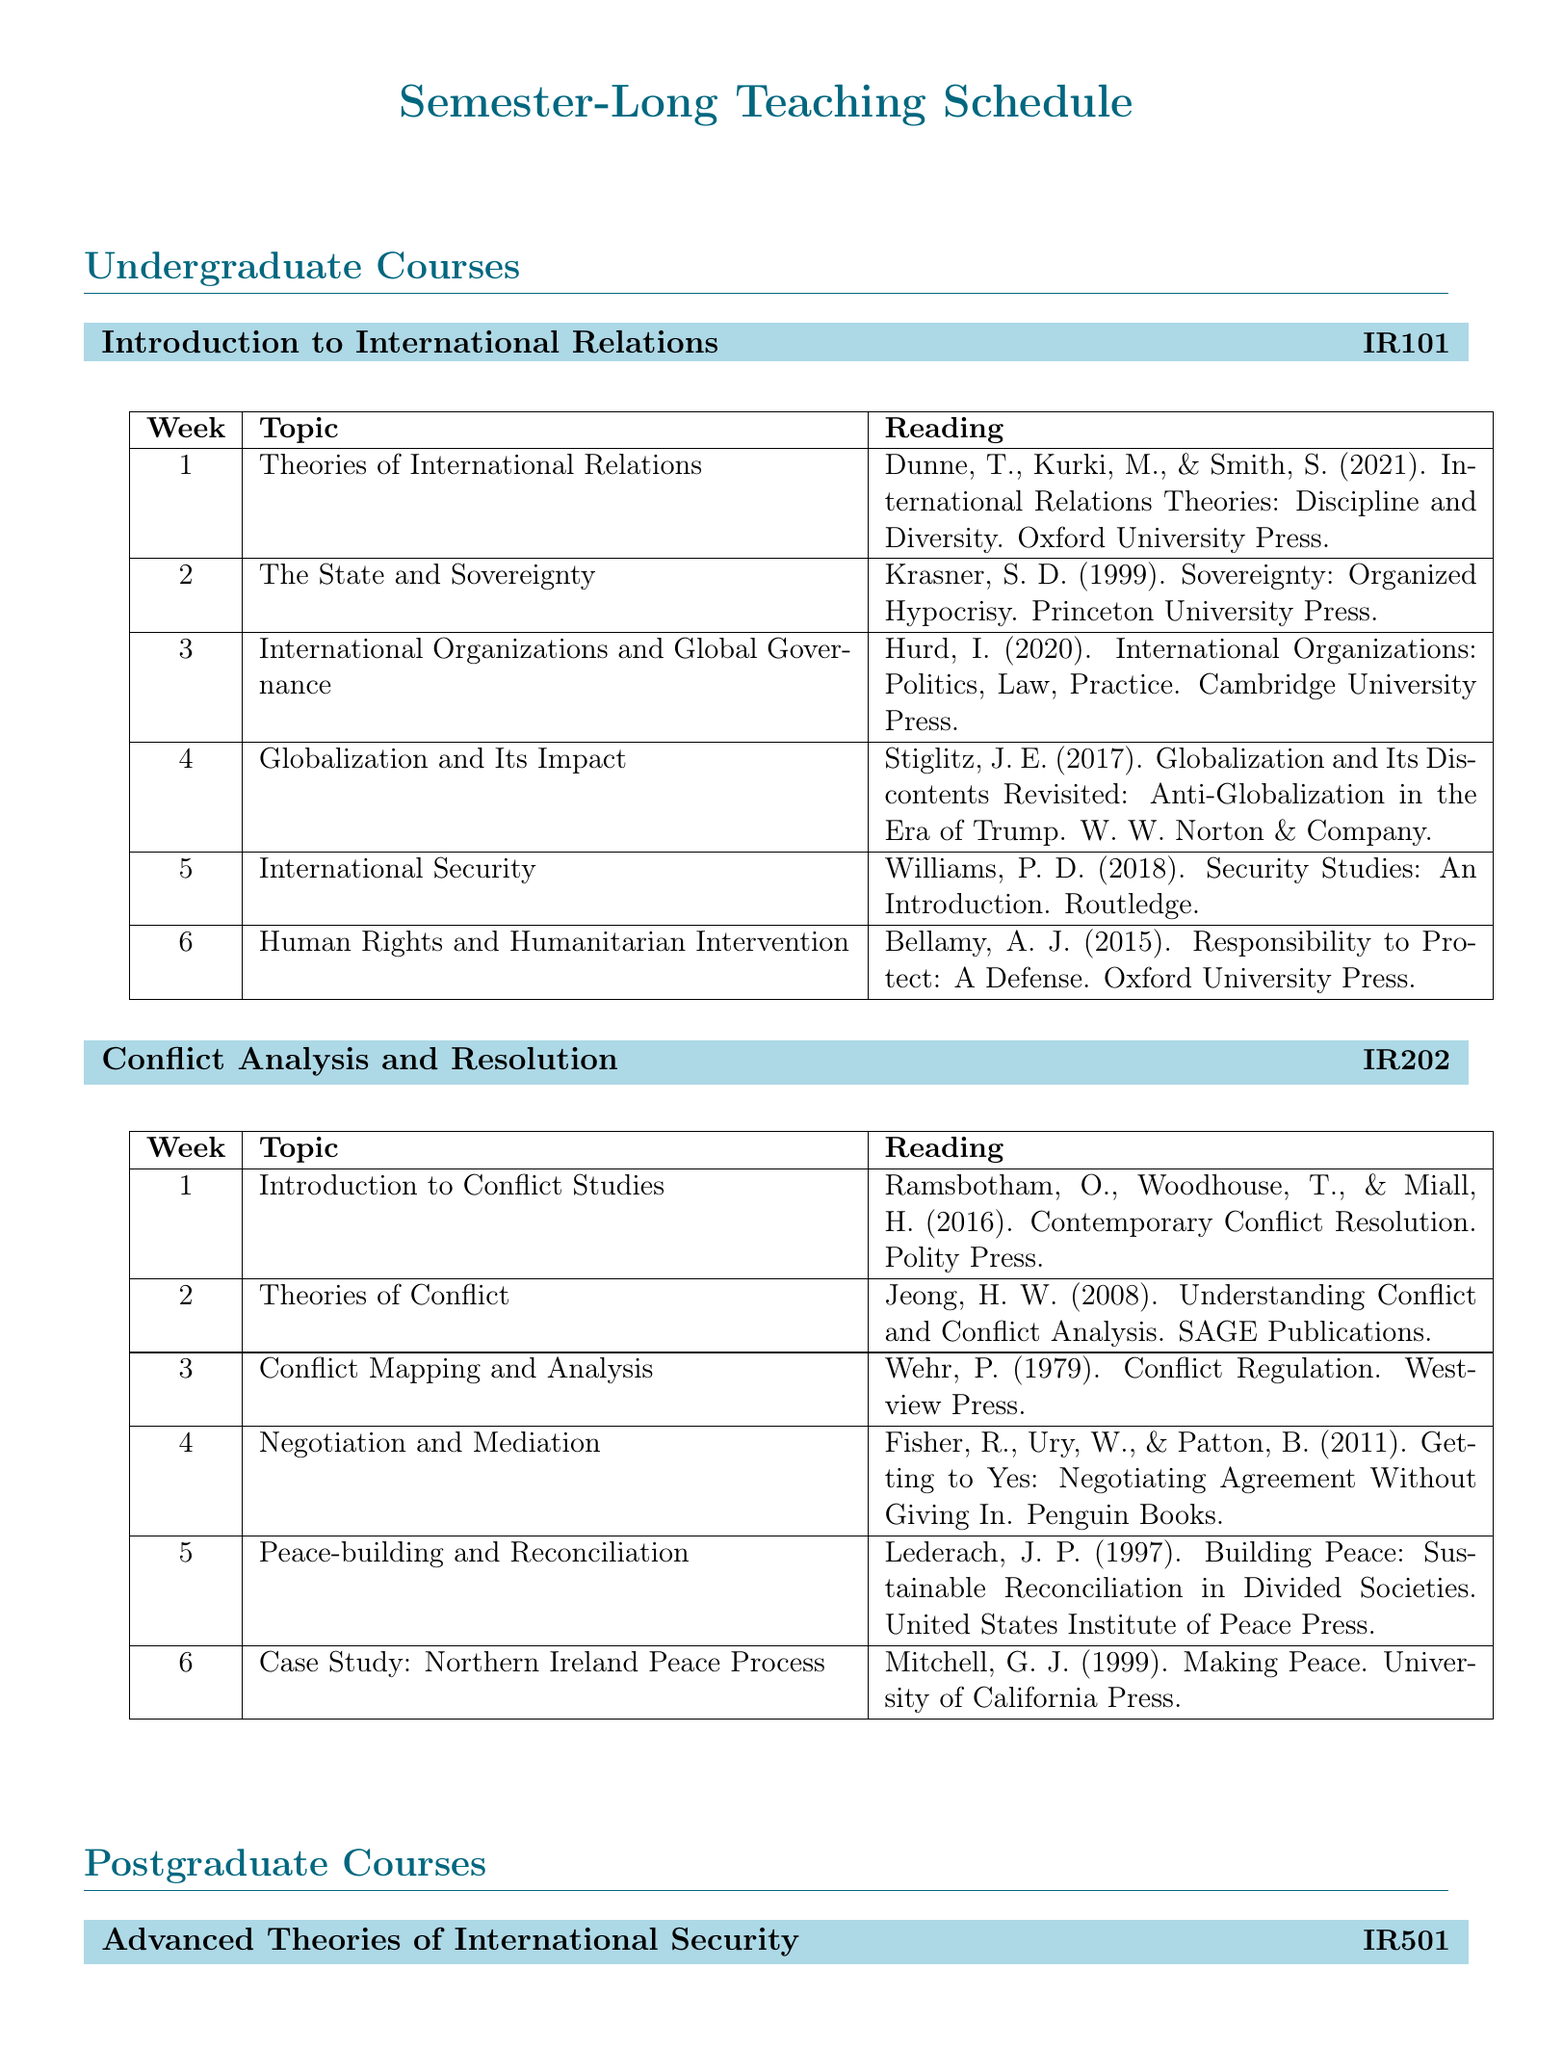What is the course code for "Introduction to International Relations"? The course code is specified in the document under the course title, "Introduction to International Relations".
Answer: IR101 How many weeks does the undergraduate course "Conflict Analysis and Resolution" cover? The document lists the topics for each week, showing that the course spans twelve weeks.
Answer: 12 Who authored the reading for week 6 of "Advanced Theories of International Security"? The reading is attributed to specific authors, which can be found in the week 6 section of the postgraduate course.
Answer: Newman What topic is covered in week 4 of "Peace and Conflict Studies: Contemporary Challenges"? The document explicitly lists the topics per week, allowing us to identify the topic for week 4 of the course.
Answer: Responsibility to Protect (R2P) and Humanitarian Intervention Which book is referenced for week 11 of "Conflict Analysis and Resolution"? The reading for each week is provided, allowing easy identification of the referenced book for that specific week.
Answer: Unspeakable Truths: Transitional Justice and the Challenge of Truth Commissions What is the title of the reading assigned for week 2 in "Introduction to International Relations"? The document specifies assigned readings under each week, indicating the title for week 2 of this course.
Answer: Sovereignty: Organized Hypocrisy Which course includes a case study on the Northern Ireland Peace Process? The course is mentioned in the section listing weekly topics, allowing identification based on the specified case study.
Answer: Conflict Analysis and Resolution What is the reading for week 10 of the postgraduate course "Peace and Conflict Studies: Contemporary Challenges"? The week-by-week readings are listed, indicating the specific reading material for week 10 of the course.
Answer: Climate Wars: What People Will Be Killed For in the 21st Century 